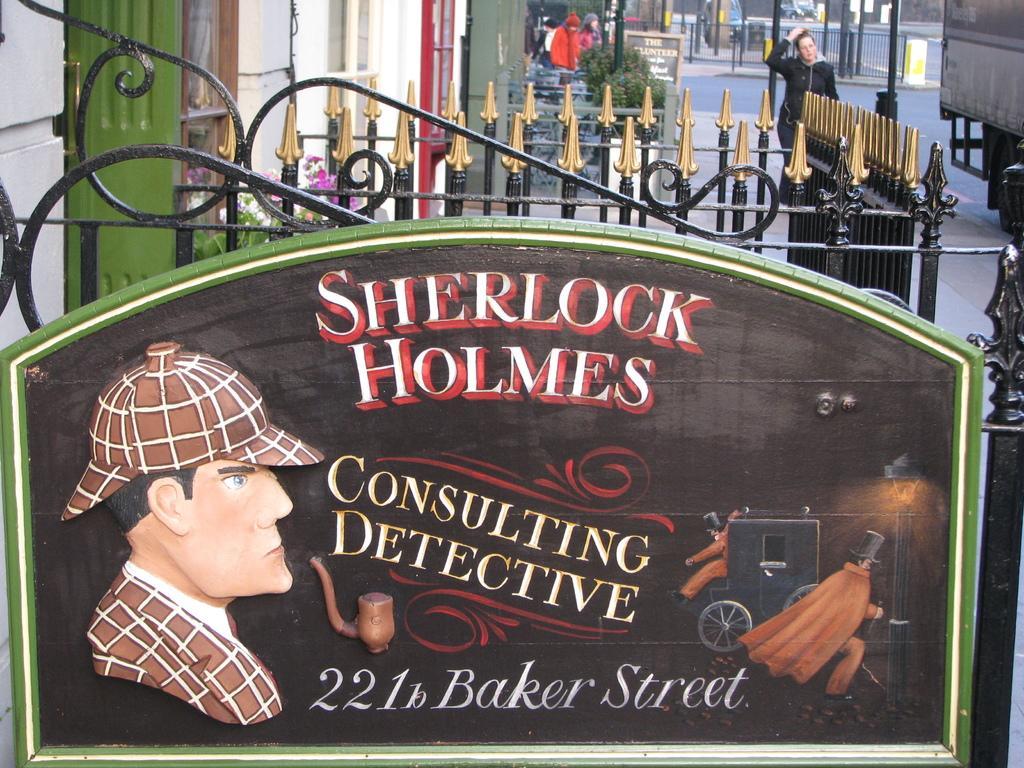Please provide a concise description of this image. In this picture I can see name boards, there are group of people standing, there are iron grilles, there are vehicles on the road and there are plants. 